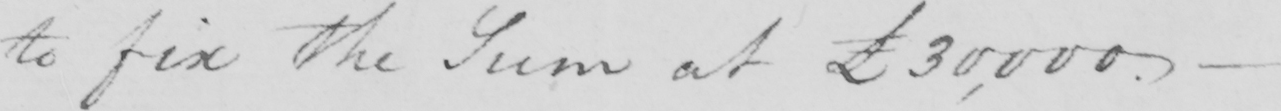Please transcribe the handwritten text in this image. to fix the Sum at £30,000  . _ 